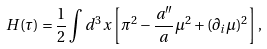<formula> <loc_0><loc_0><loc_500><loc_500>H ( \tau ) = \frac { 1 } { 2 } \int d ^ { 3 } x \left [ \pi ^ { 2 } - \frac { a ^ { \prime \prime } } { a } \mu ^ { 2 } + ( \partial _ { i } \mu ) ^ { 2 } \right ] ,</formula> 